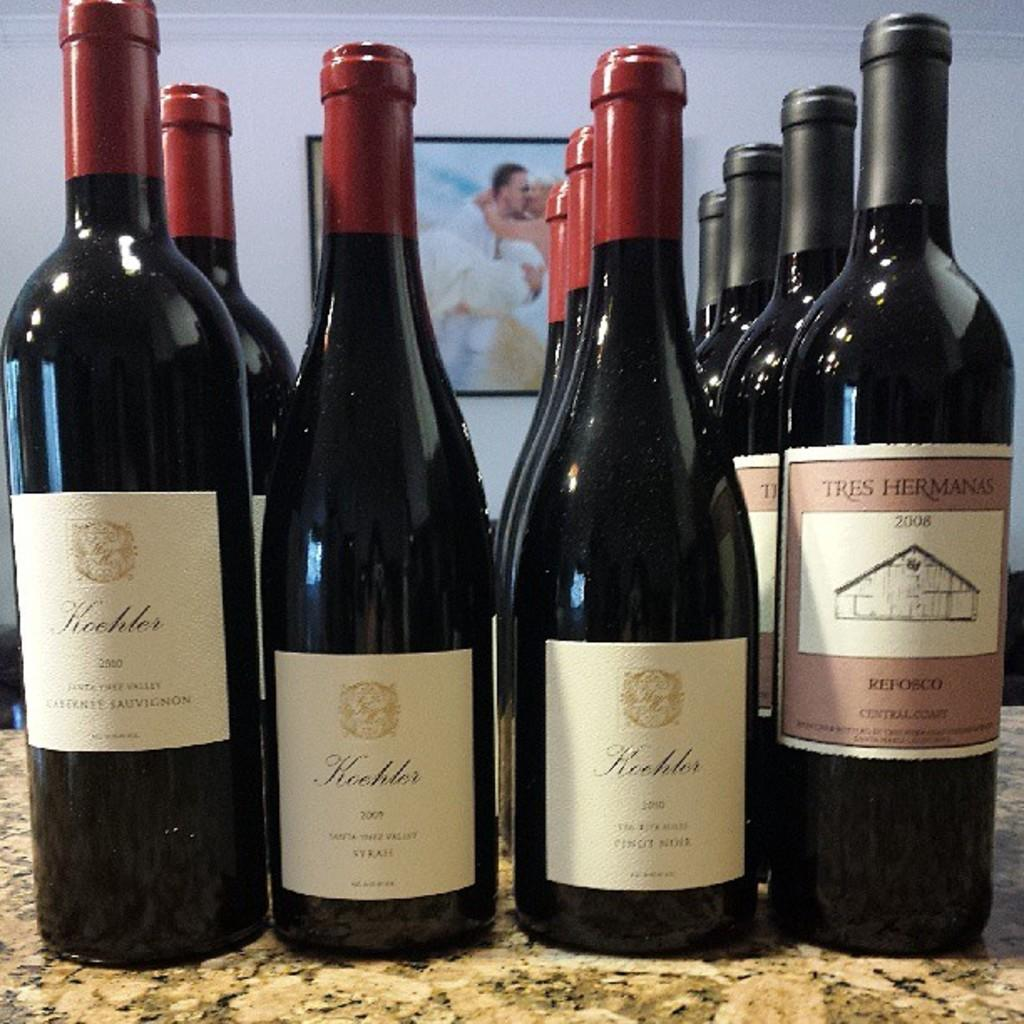<image>
Render a clear and concise summary of the photo. the year 2009 is on the front of the wine bottle 